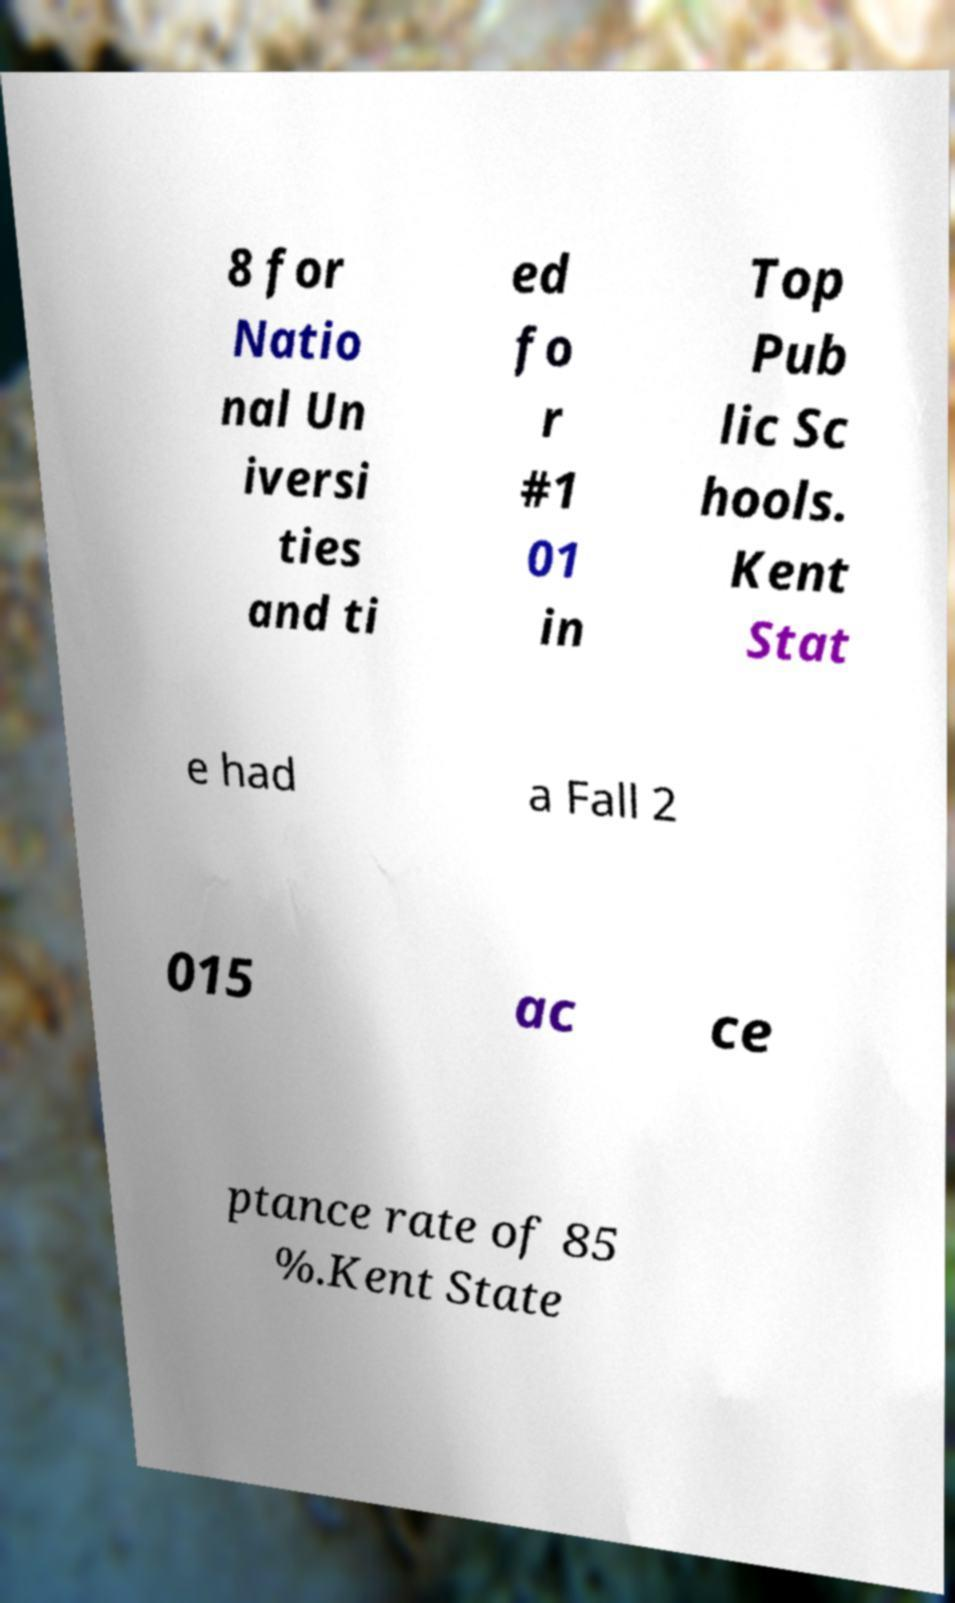Could you extract and type out the text from this image? 8 for Natio nal Un iversi ties and ti ed fo r #1 01 in Top Pub lic Sc hools. Kent Stat e had a Fall 2 015 ac ce ptance rate of 85 %.Kent State 